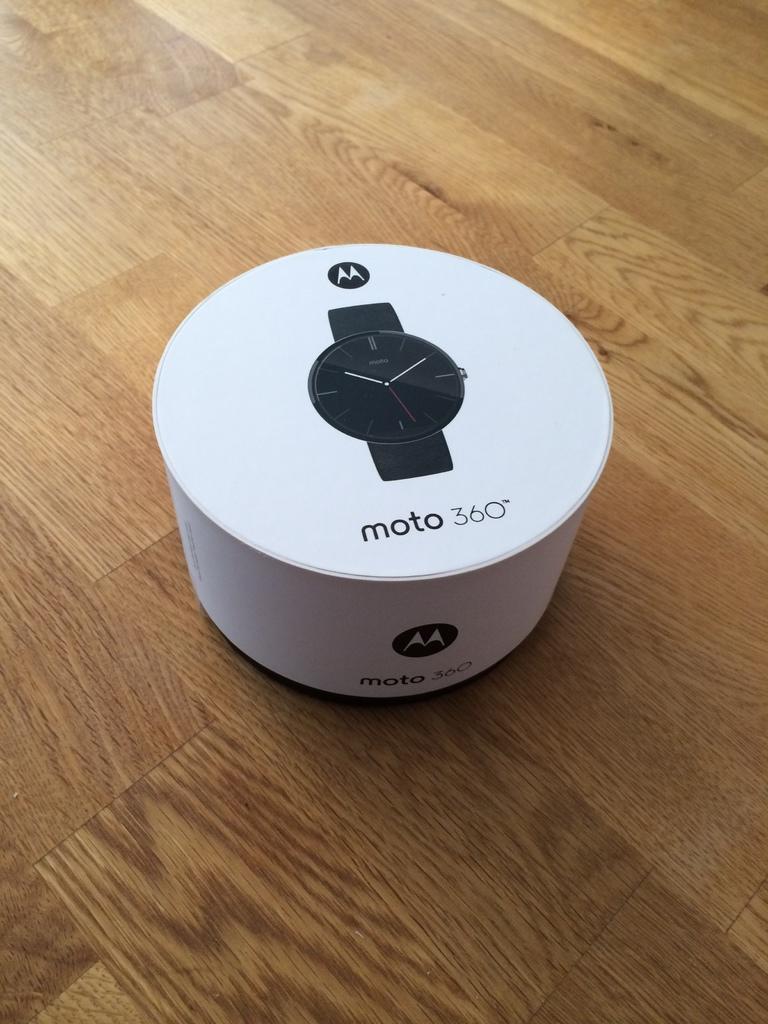What is the brand of this watch?
Offer a terse response. Motorola. What model is shown?
Provide a succinct answer. Moto 360. 